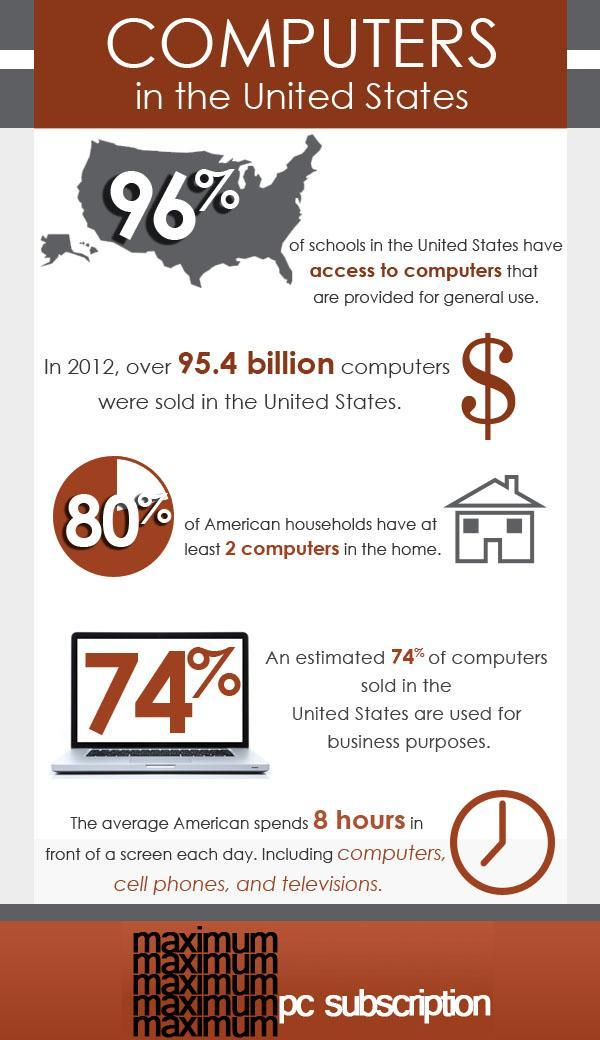What is the estimated percentage of computers sold in the U.S. for business purposes?
Answer the question with a short phrase. 74% What percentage of schools in the United States do not have access to computers? 4% 